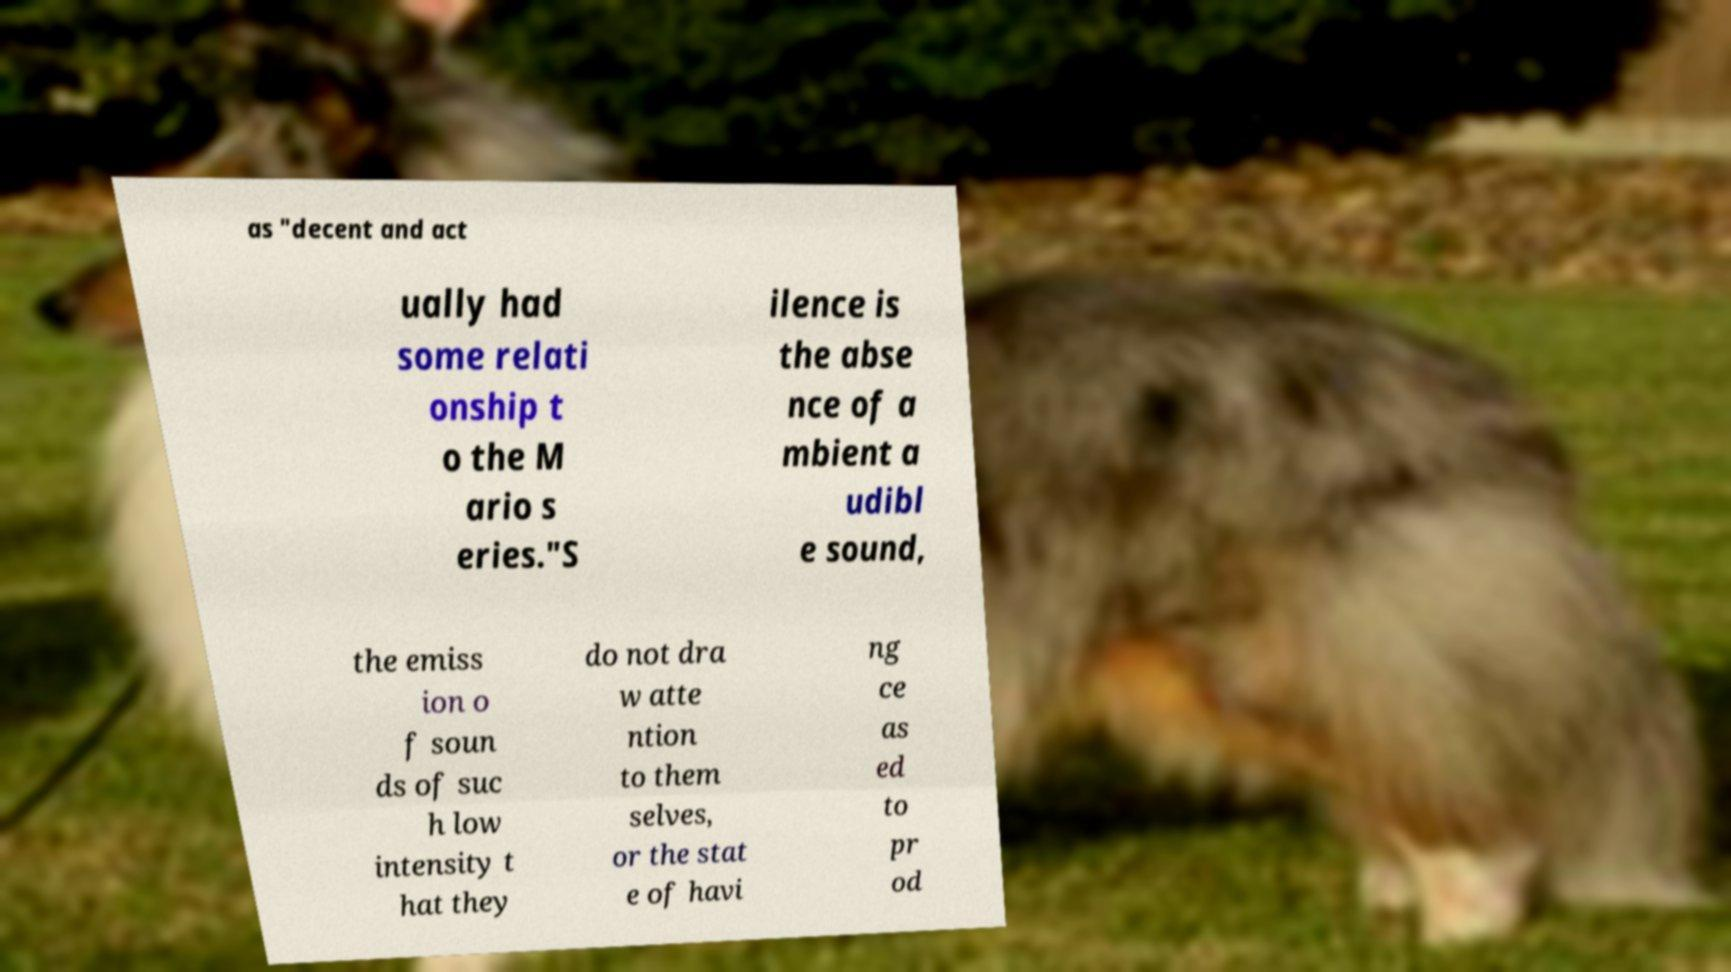Could you assist in decoding the text presented in this image and type it out clearly? as "decent and act ually had some relati onship t o the M ario s eries."S ilence is the abse nce of a mbient a udibl e sound, the emiss ion o f soun ds of suc h low intensity t hat they do not dra w atte ntion to them selves, or the stat e of havi ng ce as ed to pr od 